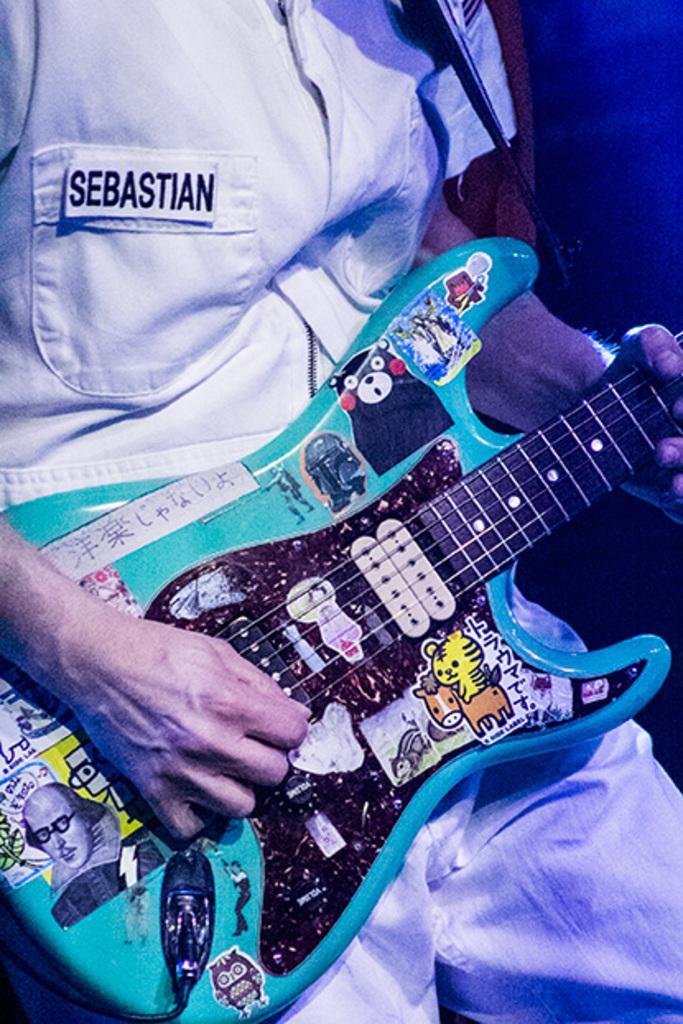Could you give a brief overview of what you see in this image? In the image i can see a person holding a musical instrument in his hand and a text written on his shirt. 